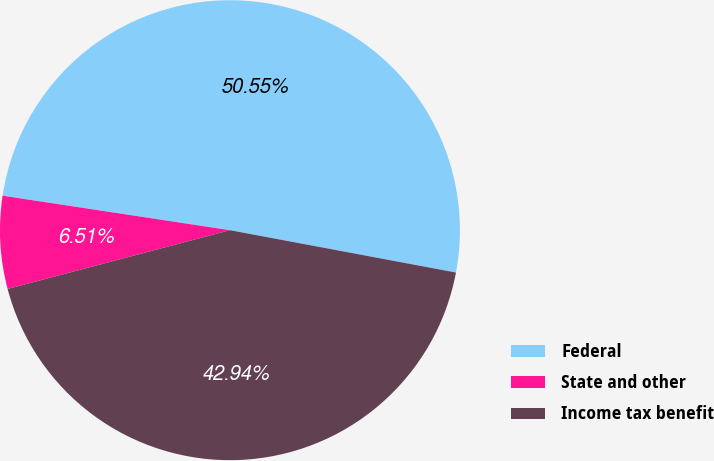Convert chart. <chart><loc_0><loc_0><loc_500><loc_500><pie_chart><fcel>Federal<fcel>State and other<fcel>Income tax benefit<nl><fcel>50.55%<fcel>6.51%<fcel>42.94%<nl></chart> 